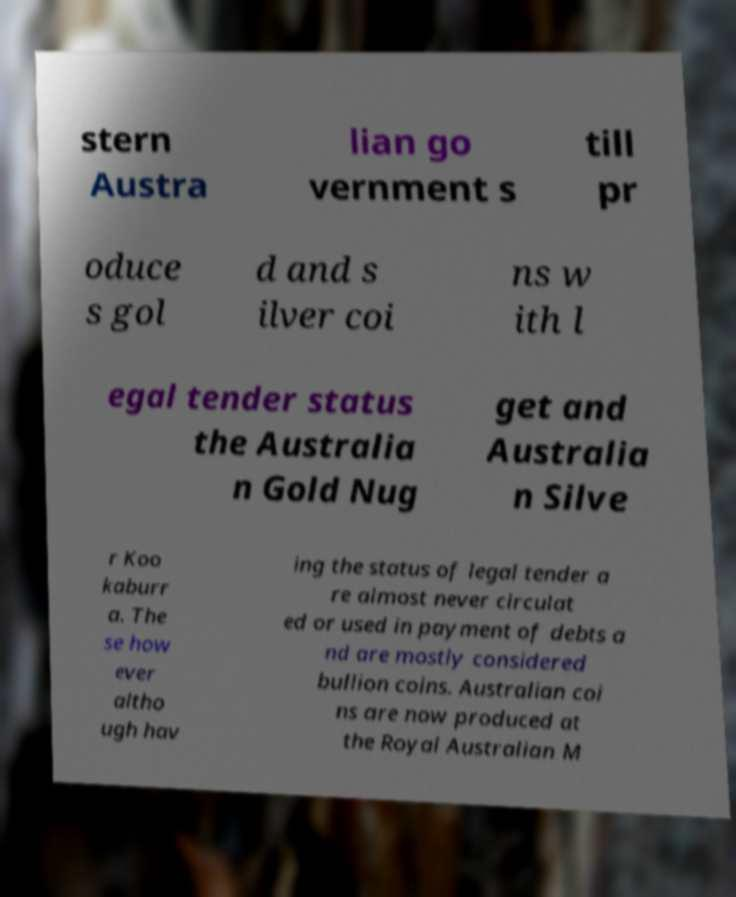Could you assist in decoding the text presented in this image and type it out clearly? stern Austra lian go vernment s till pr oduce s gol d and s ilver coi ns w ith l egal tender status the Australia n Gold Nug get and Australia n Silve r Koo kaburr a. The se how ever altho ugh hav ing the status of legal tender a re almost never circulat ed or used in payment of debts a nd are mostly considered bullion coins. Australian coi ns are now produced at the Royal Australian M 